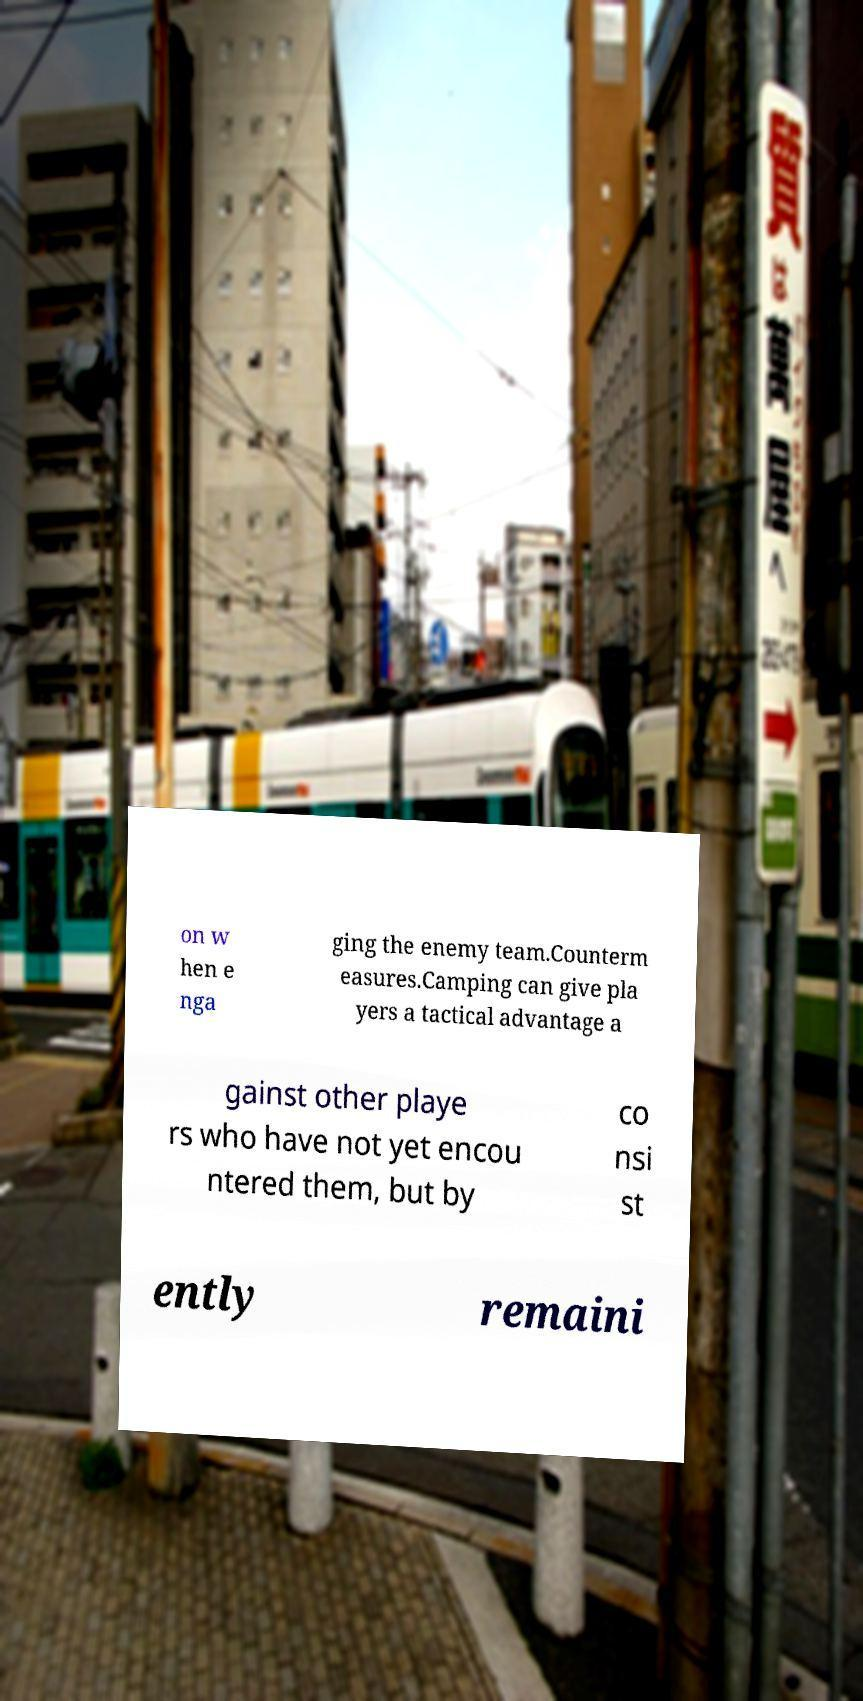Please identify and transcribe the text found in this image. on w hen e nga ging the enemy team.Counterm easures.Camping can give pla yers a tactical advantage a gainst other playe rs who have not yet encou ntered them, but by co nsi st ently remaini 